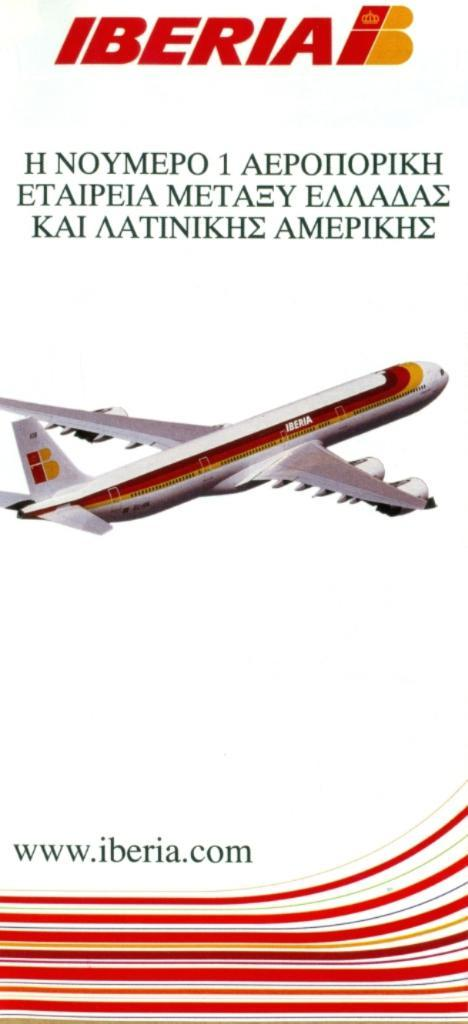<image>
Describe the image concisely. A pamphlet for Iberia has a drawing of a plane on it. 